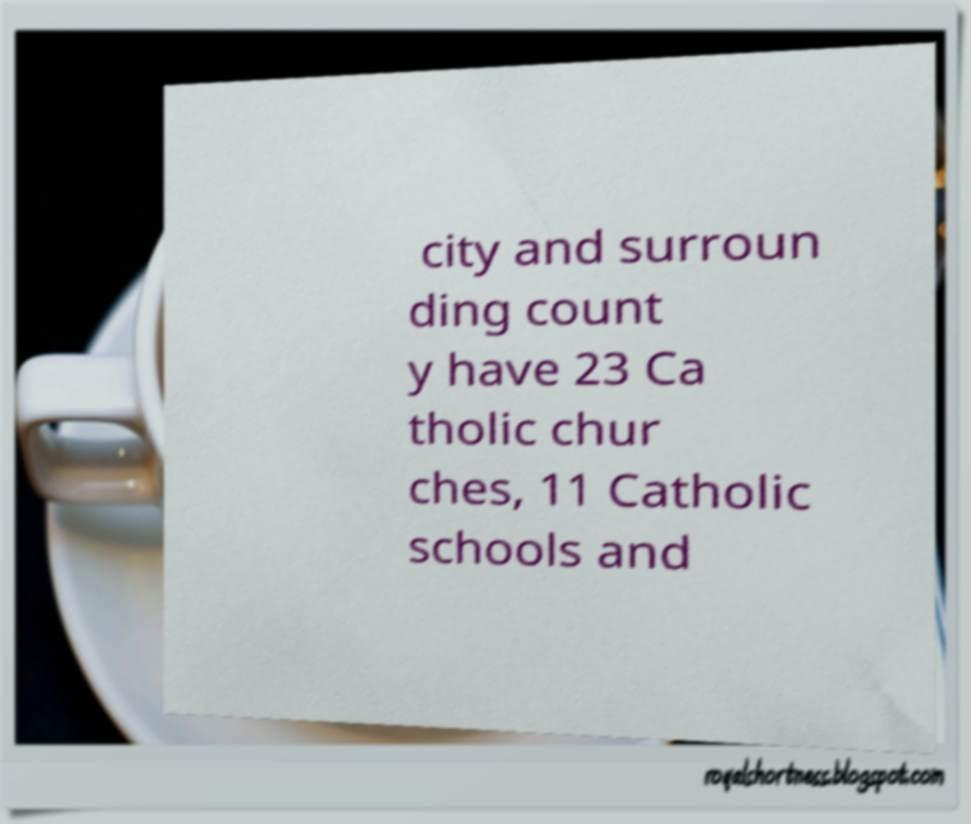Please read and relay the text visible in this image. What does it say? city and surroun ding count y have 23 Ca tholic chur ches, 11 Catholic schools and 